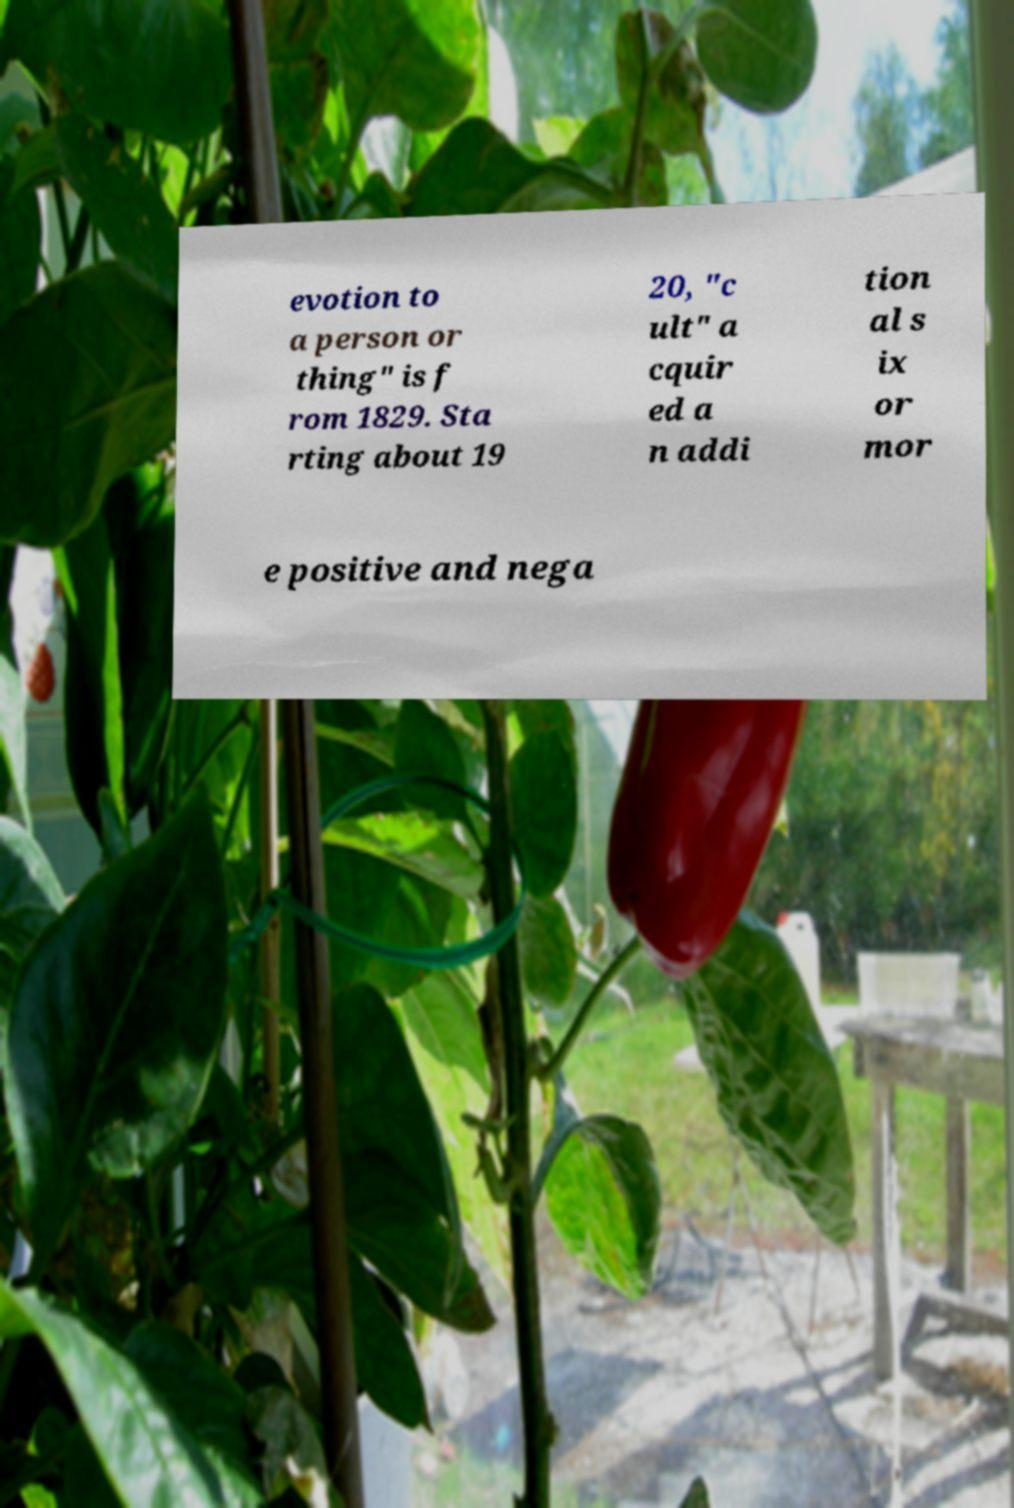Could you extract and type out the text from this image? evotion to a person or thing" is f rom 1829. Sta rting about 19 20, "c ult" a cquir ed a n addi tion al s ix or mor e positive and nega 